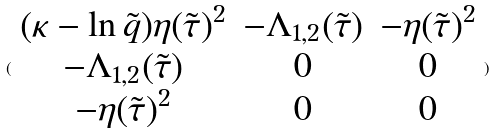Convert formula to latex. <formula><loc_0><loc_0><loc_500><loc_500>( \begin{array} { c c c } ( \kappa - \ln \tilde { q } ) \eta ( \tilde { \tau } ) ^ { 2 } & - \Lambda _ { 1 , 2 } ( \tilde { \tau } ) & - \eta ( \tilde { \tau } ) ^ { 2 } \\ - \Lambda _ { 1 , 2 } ( \tilde { \tau } ) & 0 & 0 \\ - \eta ( \tilde { \tau } ) ^ { 2 } & 0 & 0 \end{array} )</formula> 